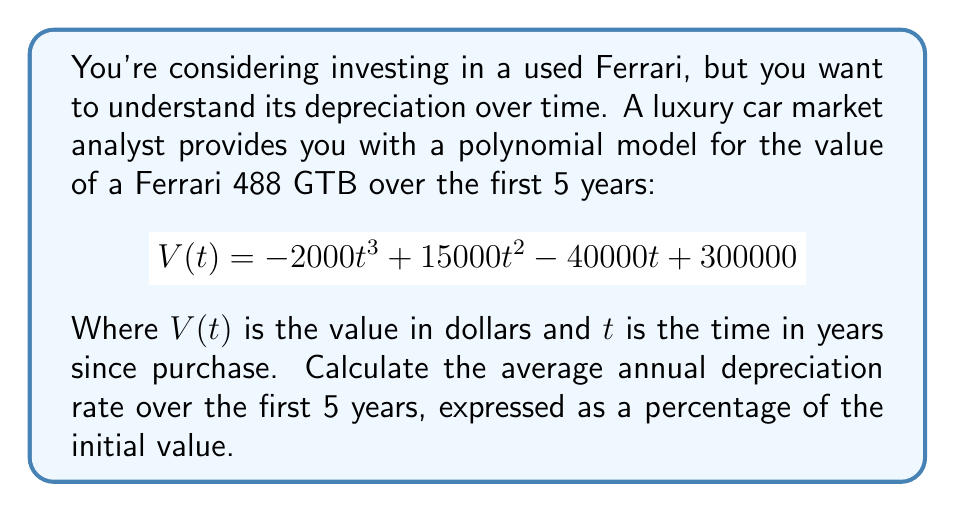Provide a solution to this math problem. To solve this problem, we'll follow these steps:

1) Find the initial value of the car (at t = 0):
   $$V(0) = -2000(0)^3 + 15000(0)^2 - 40000(0) + 300000 = 300000$$
   The initial value is $300,000.

2) Find the value after 5 years (at t = 5):
   $$V(5) = -2000(5)^3 + 15000(5)^2 - 40000(5) + 300000$$
   $$= -250000 + 375000 - 200000 + 300000 = 225000$$

3) Calculate the total depreciation over 5 years:
   Total depreciation = Initial value - Value after 5 years
   $$300000 - 225000 = 75000$$

4) Calculate the average annual depreciation:
   Average annual depreciation = Total depreciation ÷ Number of years
   $$75000 \div 5 = 15000$$

5) Express this as a percentage of the initial value:
   Annual depreciation rate = (Average annual depreciation ÷ Initial value) × 100%
   $$(15000 \div 300000) \times 100\% = 0.05 \times 100\% = 5\%$$

Therefore, the average annual depreciation rate over the first 5 years is 5% of the initial value.
Answer: 5% 